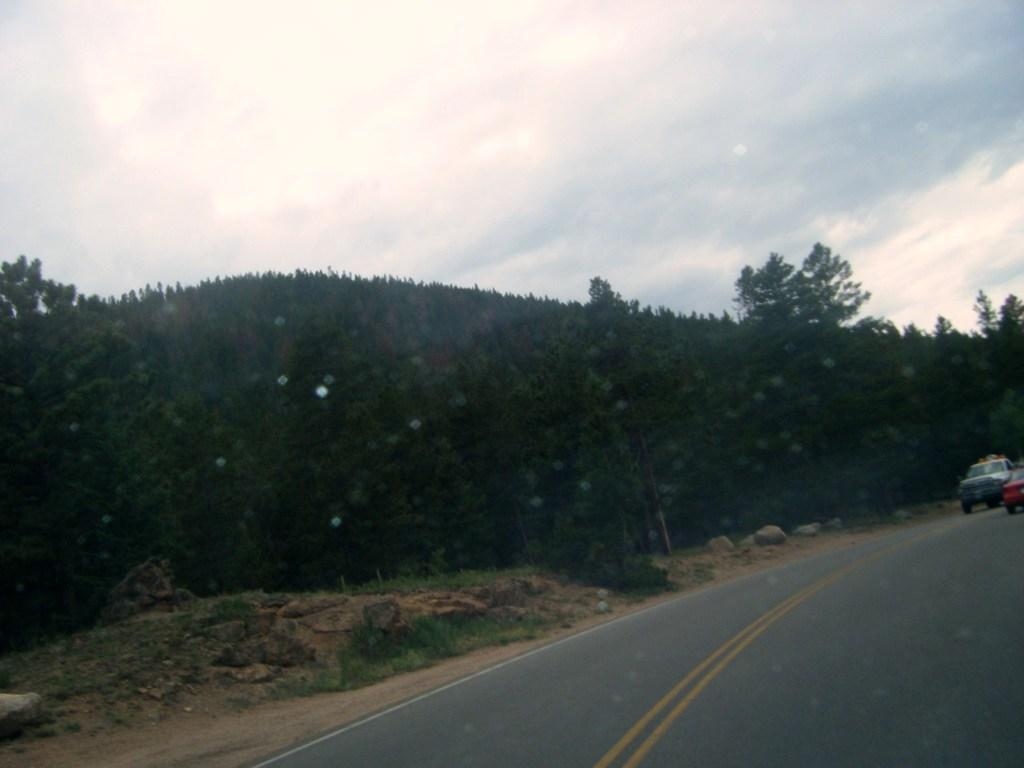What can be seen beside the road in the image? There are trees beside the road in the image. How many vehicles are on the road in the image? There are two vehicles on the road in the image. What type of fruit is being taught in the image? There is no fruit or teaching activity present in the image. What kind of powder is visible on the road in the image? There is no powder visible on the road in the image. 